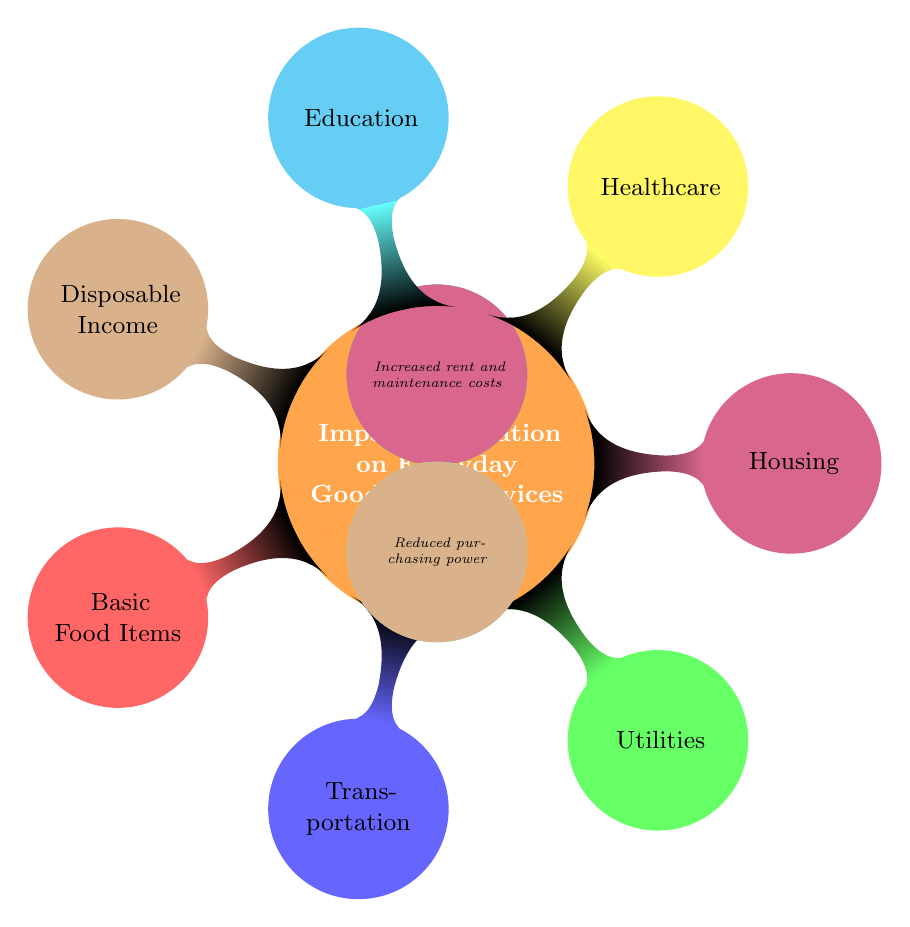What's the first node in the diagram? The first node in the diagram is labeled "Impact of Inflation on Everyday Goods and Services," which is the central concept of the mind map.
Answer: Impact of Inflation on Everyday Goods and Services How many categories are impacted by inflation in the diagram? The diagram shows six distinct categories affected by inflation, each represented as a child node.
Answer: Six What are two basic food items mentioned in the diagram? The child node under Basic Food Items states "Rising costs of bread, milk, and vegetables", so bread and milk are two items specifically mentioned.
Answer: Bread, Milk Which category has a higher cost pertaining to transportation? The node under Transportation indicates "Increased fuel prices and transportation fares," highlighting that both aspects are related to higher costs.
Answer: Transportation fares What colored node represents healthcare costs? The node associated with healthcare costs is colored yellow, as indicated in the diagram's coding.
Answer: Yellow Which category mentions reduced purchasing power? The child node labeled "Disposable Income" indicates that this category is tied to reduced purchasing power due to inflation.
Answer: Disposable Income Explain the relationship between basic food items and utilities. Basic food items refer to essential groceries affected by rising costs, and utilities represent increased costs for services like gas and electricity; both highlight essential living costs impacting daily budgets.
Answer: Both highlight essential living costs Which category relates to higher medical and pharmaceutical costs? The node labeled Healthcare indicates that it pertains to higher costs in the medical and pharmaceutical sectors based on the description.
Answer: Healthcare Does the diagram suggest that housing costs have increased? Yes, the node under Housing states "Increased rent and maintenance costs," indicating that these costs have indeed risen due to inflation.
Answer: Yes What is the primary focus of the diagram? The diagram primarily focuses on the various everyday goods and services that have been impacted by inflation over the past year.
Answer: Everyday goods and services impacted by inflation 